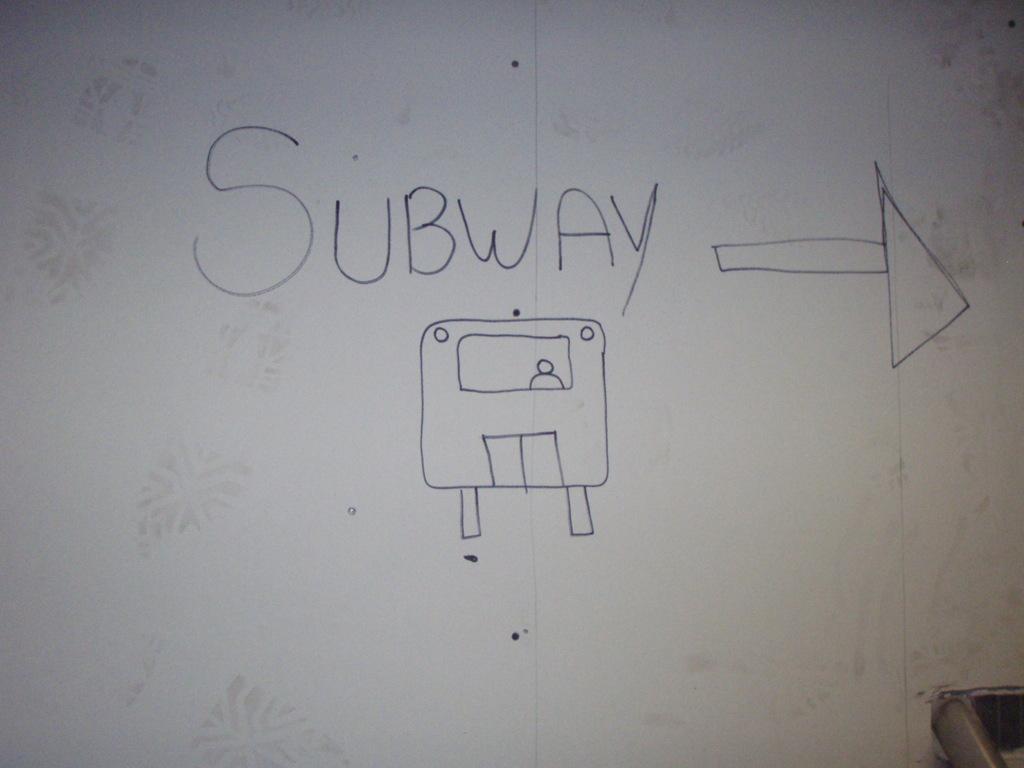What is nearby?
Provide a short and direct response. Subway. What word is above the bus?
Provide a short and direct response. Subway. 